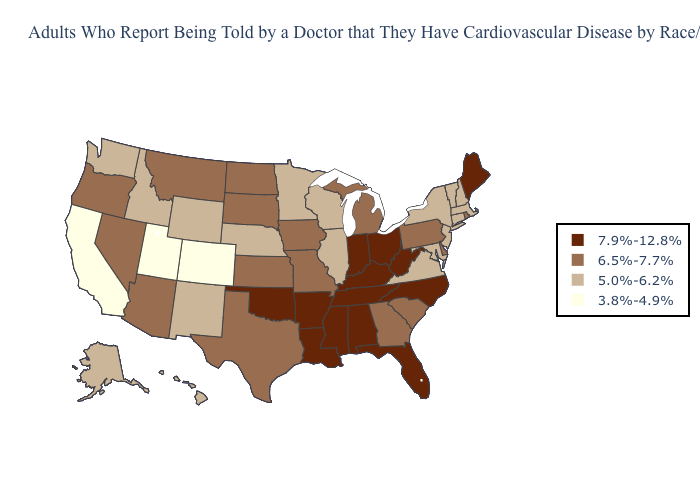Does Virginia have the highest value in the USA?
Quick response, please. No. How many symbols are there in the legend?
Short answer required. 4. What is the value of Alaska?
Quick response, please. 5.0%-6.2%. What is the highest value in states that border Illinois?
Be succinct. 7.9%-12.8%. Does Texas have a lower value than New York?
Write a very short answer. No. Among the states that border Indiana , which have the highest value?
Short answer required. Kentucky, Ohio. Name the states that have a value in the range 7.9%-12.8%?
Write a very short answer. Alabama, Arkansas, Florida, Indiana, Kentucky, Louisiana, Maine, Mississippi, North Carolina, Ohio, Oklahoma, Tennessee, West Virginia. What is the lowest value in the West?
Keep it brief. 3.8%-4.9%. Which states hav the highest value in the Northeast?
Be succinct. Maine. Does Georgia have the lowest value in the USA?
Answer briefly. No. What is the highest value in the West ?
Quick response, please. 6.5%-7.7%. Name the states that have a value in the range 7.9%-12.8%?
Concise answer only. Alabama, Arkansas, Florida, Indiana, Kentucky, Louisiana, Maine, Mississippi, North Carolina, Ohio, Oklahoma, Tennessee, West Virginia. Name the states that have a value in the range 6.5%-7.7%?
Write a very short answer. Arizona, Delaware, Georgia, Iowa, Kansas, Michigan, Missouri, Montana, Nevada, North Dakota, Oregon, Pennsylvania, Rhode Island, South Carolina, South Dakota, Texas. Does New Jersey have the highest value in the Northeast?
Give a very brief answer. No. Among the states that border Illinois , does Missouri have the highest value?
Quick response, please. No. 